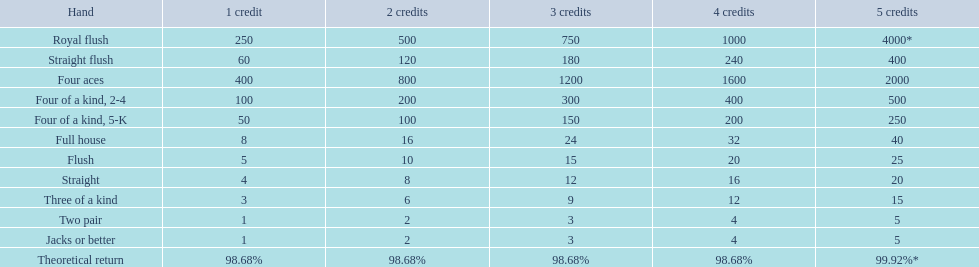In poker, what hand comes beneath a straight flush? Four aces. What hand comes beneath four aces? Four of a kind, 2-4. When comparing a straight and a flush, which one holds a greater rank? Flush. 